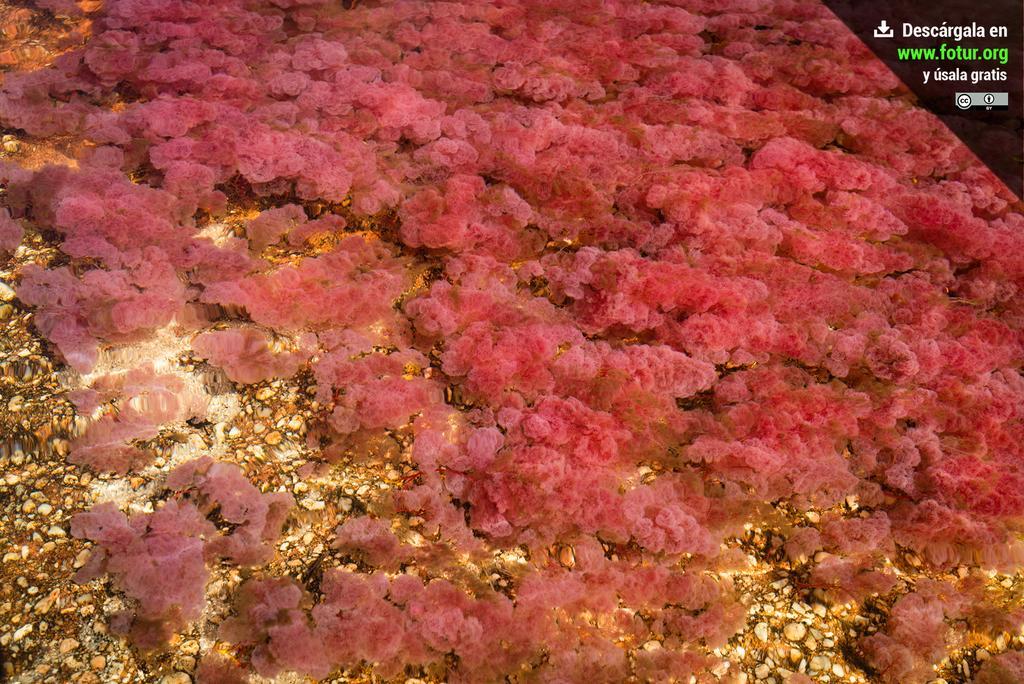How would you summarize this image in a sentence or two? In the foreground of this image, it seems like sea algae under the water. 